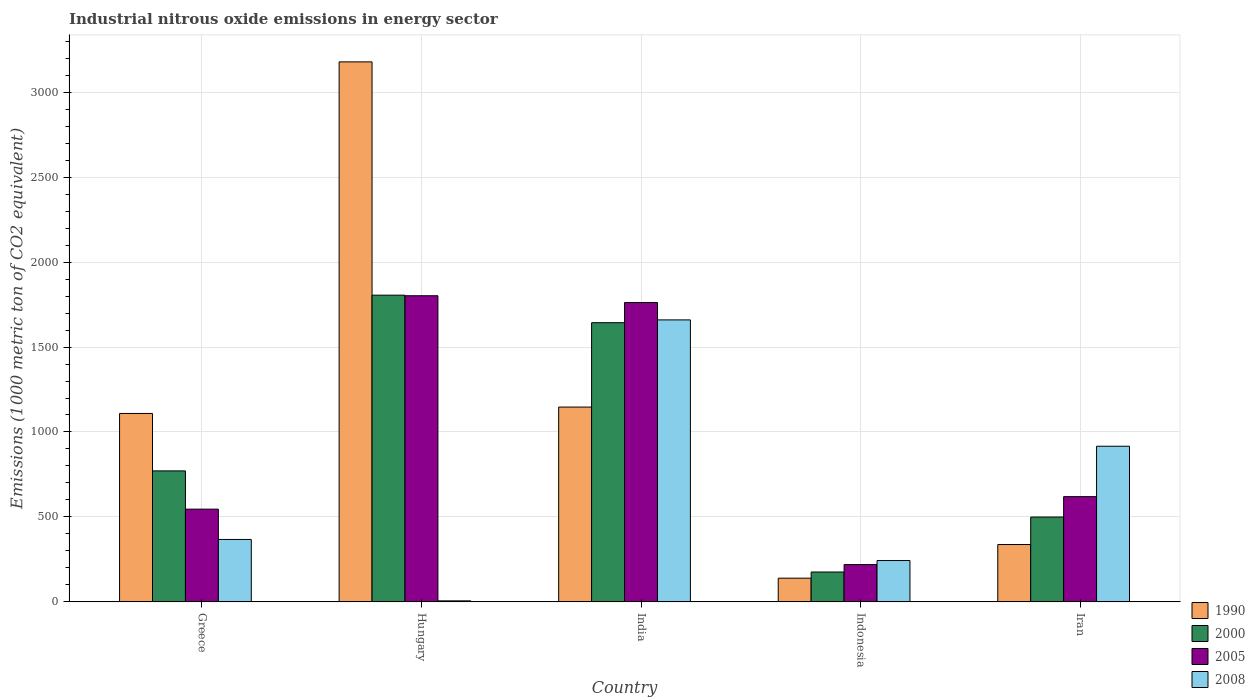Are the number of bars per tick equal to the number of legend labels?
Offer a terse response. Yes. How many bars are there on the 2nd tick from the left?
Provide a succinct answer. 4. In how many cases, is the number of bars for a given country not equal to the number of legend labels?
Offer a very short reply. 0. What is the amount of industrial nitrous oxide emitted in 2005 in Greece?
Ensure brevity in your answer.  545.8. Across all countries, what is the maximum amount of industrial nitrous oxide emitted in 1990?
Your response must be concise. 3178.6. Across all countries, what is the minimum amount of industrial nitrous oxide emitted in 2008?
Offer a terse response. 6. In which country was the amount of industrial nitrous oxide emitted in 2008 maximum?
Provide a succinct answer. India. In which country was the amount of industrial nitrous oxide emitted in 1990 minimum?
Offer a very short reply. Indonesia. What is the total amount of industrial nitrous oxide emitted in 2000 in the graph?
Provide a succinct answer. 4894.9. What is the difference between the amount of industrial nitrous oxide emitted in 2000 in Hungary and that in India?
Provide a short and direct response. 162.1. What is the difference between the amount of industrial nitrous oxide emitted in 1990 in Indonesia and the amount of industrial nitrous oxide emitted in 2008 in India?
Provide a succinct answer. -1520.3. What is the average amount of industrial nitrous oxide emitted in 2008 per country?
Offer a very short reply. 638.54. What is the difference between the amount of industrial nitrous oxide emitted of/in 2008 and amount of industrial nitrous oxide emitted of/in 1990 in Indonesia?
Offer a terse response. 103.8. In how many countries, is the amount of industrial nitrous oxide emitted in 2000 greater than 600 1000 metric ton?
Provide a succinct answer. 3. What is the ratio of the amount of industrial nitrous oxide emitted in 2008 in Greece to that in India?
Give a very brief answer. 0.22. Is the amount of industrial nitrous oxide emitted in 2005 in Hungary less than that in Indonesia?
Offer a very short reply. No. Is the difference between the amount of industrial nitrous oxide emitted in 2008 in India and Iran greater than the difference between the amount of industrial nitrous oxide emitted in 1990 in India and Iran?
Provide a short and direct response. No. What is the difference between the highest and the second highest amount of industrial nitrous oxide emitted in 2000?
Ensure brevity in your answer.  -872.3. What is the difference between the highest and the lowest amount of industrial nitrous oxide emitted in 2000?
Offer a terse response. 1629.6. Is it the case that in every country, the sum of the amount of industrial nitrous oxide emitted in 2000 and amount of industrial nitrous oxide emitted in 2008 is greater than the sum of amount of industrial nitrous oxide emitted in 2005 and amount of industrial nitrous oxide emitted in 1990?
Your response must be concise. No. What does the 3rd bar from the left in Hungary represents?
Ensure brevity in your answer.  2005. What does the 3rd bar from the right in Indonesia represents?
Offer a very short reply. 2000. Is it the case that in every country, the sum of the amount of industrial nitrous oxide emitted in 2008 and amount of industrial nitrous oxide emitted in 2000 is greater than the amount of industrial nitrous oxide emitted in 2005?
Offer a very short reply. Yes. How many bars are there?
Keep it short and to the point. 20. How many countries are there in the graph?
Your answer should be very brief. 5. What is the difference between two consecutive major ticks on the Y-axis?
Ensure brevity in your answer.  500. Where does the legend appear in the graph?
Offer a very short reply. Bottom right. How many legend labels are there?
Keep it short and to the point. 4. What is the title of the graph?
Your answer should be compact. Industrial nitrous oxide emissions in energy sector. Does "1995" appear as one of the legend labels in the graph?
Ensure brevity in your answer.  No. What is the label or title of the Y-axis?
Your answer should be very brief. Emissions (1000 metric ton of CO2 equivalent). What is the Emissions (1000 metric ton of CO2 equivalent) in 1990 in Greece?
Your response must be concise. 1109.1. What is the Emissions (1000 metric ton of CO2 equivalent) of 2000 in Greece?
Your response must be concise. 771. What is the Emissions (1000 metric ton of CO2 equivalent) of 2005 in Greece?
Give a very brief answer. 545.8. What is the Emissions (1000 metric ton of CO2 equivalent) in 2008 in Greece?
Your answer should be very brief. 367.4. What is the Emissions (1000 metric ton of CO2 equivalent) in 1990 in Hungary?
Keep it short and to the point. 3178.6. What is the Emissions (1000 metric ton of CO2 equivalent) in 2000 in Hungary?
Your answer should be compact. 1805.4. What is the Emissions (1000 metric ton of CO2 equivalent) in 2005 in Hungary?
Provide a succinct answer. 1802. What is the Emissions (1000 metric ton of CO2 equivalent) of 1990 in India?
Your response must be concise. 1146.7. What is the Emissions (1000 metric ton of CO2 equivalent) of 2000 in India?
Your response must be concise. 1643.3. What is the Emissions (1000 metric ton of CO2 equivalent) of 2005 in India?
Your response must be concise. 1761.9. What is the Emissions (1000 metric ton of CO2 equivalent) of 2008 in India?
Provide a short and direct response. 1659.8. What is the Emissions (1000 metric ton of CO2 equivalent) of 1990 in Indonesia?
Offer a terse response. 139.5. What is the Emissions (1000 metric ton of CO2 equivalent) in 2000 in Indonesia?
Your answer should be compact. 175.8. What is the Emissions (1000 metric ton of CO2 equivalent) of 2005 in Indonesia?
Offer a very short reply. 219.6. What is the Emissions (1000 metric ton of CO2 equivalent) in 2008 in Indonesia?
Your answer should be compact. 243.3. What is the Emissions (1000 metric ton of CO2 equivalent) of 1990 in Iran?
Offer a terse response. 337.6. What is the Emissions (1000 metric ton of CO2 equivalent) of 2000 in Iran?
Make the answer very short. 499.4. What is the Emissions (1000 metric ton of CO2 equivalent) of 2005 in Iran?
Offer a very short reply. 619.4. What is the Emissions (1000 metric ton of CO2 equivalent) in 2008 in Iran?
Provide a succinct answer. 916.2. Across all countries, what is the maximum Emissions (1000 metric ton of CO2 equivalent) of 1990?
Provide a short and direct response. 3178.6. Across all countries, what is the maximum Emissions (1000 metric ton of CO2 equivalent) of 2000?
Provide a short and direct response. 1805.4. Across all countries, what is the maximum Emissions (1000 metric ton of CO2 equivalent) of 2005?
Ensure brevity in your answer.  1802. Across all countries, what is the maximum Emissions (1000 metric ton of CO2 equivalent) in 2008?
Provide a short and direct response. 1659.8. Across all countries, what is the minimum Emissions (1000 metric ton of CO2 equivalent) in 1990?
Your answer should be compact. 139.5. Across all countries, what is the minimum Emissions (1000 metric ton of CO2 equivalent) of 2000?
Your response must be concise. 175.8. Across all countries, what is the minimum Emissions (1000 metric ton of CO2 equivalent) in 2005?
Your answer should be compact. 219.6. What is the total Emissions (1000 metric ton of CO2 equivalent) in 1990 in the graph?
Keep it short and to the point. 5911.5. What is the total Emissions (1000 metric ton of CO2 equivalent) of 2000 in the graph?
Provide a short and direct response. 4894.9. What is the total Emissions (1000 metric ton of CO2 equivalent) of 2005 in the graph?
Offer a very short reply. 4948.7. What is the total Emissions (1000 metric ton of CO2 equivalent) of 2008 in the graph?
Provide a succinct answer. 3192.7. What is the difference between the Emissions (1000 metric ton of CO2 equivalent) in 1990 in Greece and that in Hungary?
Keep it short and to the point. -2069.5. What is the difference between the Emissions (1000 metric ton of CO2 equivalent) of 2000 in Greece and that in Hungary?
Ensure brevity in your answer.  -1034.4. What is the difference between the Emissions (1000 metric ton of CO2 equivalent) in 2005 in Greece and that in Hungary?
Offer a terse response. -1256.2. What is the difference between the Emissions (1000 metric ton of CO2 equivalent) in 2008 in Greece and that in Hungary?
Offer a very short reply. 361.4. What is the difference between the Emissions (1000 metric ton of CO2 equivalent) of 1990 in Greece and that in India?
Offer a very short reply. -37.6. What is the difference between the Emissions (1000 metric ton of CO2 equivalent) of 2000 in Greece and that in India?
Your response must be concise. -872.3. What is the difference between the Emissions (1000 metric ton of CO2 equivalent) of 2005 in Greece and that in India?
Your response must be concise. -1216.1. What is the difference between the Emissions (1000 metric ton of CO2 equivalent) of 2008 in Greece and that in India?
Ensure brevity in your answer.  -1292.4. What is the difference between the Emissions (1000 metric ton of CO2 equivalent) of 1990 in Greece and that in Indonesia?
Keep it short and to the point. 969.6. What is the difference between the Emissions (1000 metric ton of CO2 equivalent) of 2000 in Greece and that in Indonesia?
Provide a succinct answer. 595.2. What is the difference between the Emissions (1000 metric ton of CO2 equivalent) in 2005 in Greece and that in Indonesia?
Offer a terse response. 326.2. What is the difference between the Emissions (1000 metric ton of CO2 equivalent) of 2008 in Greece and that in Indonesia?
Make the answer very short. 124.1. What is the difference between the Emissions (1000 metric ton of CO2 equivalent) in 1990 in Greece and that in Iran?
Your answer should be very brief. 771.5. What is the difference between the Emissions (1000 metric ton of CO2 equivalent) of 2000 in Greece and that in Iran?
Give a very brief answer. 271.6. What is the difference between the Emissions (1000 metric ton of CO2 equivalent) of 2005 in Greece and that in Iran?
Provide a short and direct response. -73.6. What is the difference between the Emissions (1000 metric ton of CO2 equivalent) in 2008 in Greece and that in Iran?
Provide a short and direct response. -548.8. What is the difference between the Emissions (1000 metric ton of CO2 equivalent) of 1990 in Hungary and that in India?
Keep it short and to the point. 2031.9. What is the difference between the Emissions (1000 metric ton of CO2 equivalent) of 2000 in Hungary and that in India?
Provide a short and direct response. 162.1. What is the difference between the Emissions (1000 metric ton of CO2 equivalent) of 2005 in Hungary and that in India?
Offer a terse response. 40.1. What is the difference between the Emissions (1000 metric ton of CO2 equivalent) in 2008 in Hungary and that in India?
Your answer should be very brief. -1653.8. What is the difference between the Emissions (1000 metric ton of CO2 equivalent) of 1990 in Hungary and that in Indonesia?
Provide a short and direct response. 3039.1. What is the difference between the Emissions (1000 metric ton of CO2 equivalent) in 2000 in Hungary and that in Indonesia?
Offer a terse response. 1629.6. What is the difference between the Emissions (1000 metric ton of CO2 equivalent) of 2005 in Hungary and that in Indonesia?
Your answer should be very brief. 1582.4. What is the difference between the Emissions (1000 metric ton of CO2 equivalent) of 2008 in Hungary and that in Indonesia?
Keep it short and to the point. -237.3. What is the difference between the Emissions (1000 metric ton of CO2 equivalent) in 1990 in Hungary and that in Iran?
Give a very brief answer. 2841. What is the difference between the Emissions (1000 metric ton of CO2 equivalent) in 2000 in Hungary and that in Iran?
Provide a short and direct response. 1306. What is the difference between the Emissions (1000 metric ton of CO2 equivalent) in 2005 in Hungary and that in Iran?
Ensure brevity in your answer.  1182.6. What is the difference between the Emissions (1000 metric ton of CO2 equivalent) of 2008 in Hungary and that in Iran?
Offer a very short reply. -910.2. What is the difference between the Emissions (1000 metric ton of CO2 equivalent) of 1990 in India and that in Indonesia?
Your answer should be compact. 1007.2. What is the difference between the Emissions (1000 metric ton of CO2 equivalent) in 2000 in India and that in Indonesia?
Make the answer very short. 1467.5. What is the difference between the Emissions (1000 metric ton of CO2 equivalent) of 2005 in India and that in Indonesia?
Make the answer very short. 1542.3. What is the difference between the Emissions (1000 metric ton of CO2 equivalent) of 2008 in India and that in Indonesia?
Keep it short and to the point. 1416.5. What is the difference between the Emissions (1000 metric ton of CO2 equivalent) of 1990 in India and that in Iran?
Keep it short and to the point. 809.1. What is the difference between the Emissions (1000 metric ton of CO2 equivalent) of 2000 in India and that in Iran?
Make the answer very short. 1143.9. What is the difference between the Emissions (1000 metric ton of CO2 equivalent) of 2005 in India and that in Iran?
Keep it short and to the point. 1142.5. What is the difference between the Emissions (1000 metric ton of CO2 equivalent) in 2008 in India and that in Iran?
Your answer should be compact. 743.6. What is the difference between the Emissions (1000 metric ton of CO2 equivalent) in 1990 in Indonesia and that in Iran?
Provide a short and direct response. -198.1. What is the difference between the Emissions (1000 metric ton of CO2 equivalent) of 2000 in Indonesia and that in Iran?
Provide a succinct answer. -323.6. What is the difference between the Emissions (1000 metric ton of CO2 equivalent) in 2005 in Indonesia and that in Iran?
Make the answer very short. -399.8. What is the difference between the Emissions (1000 metric ton of CO2 equivalent) of 2008 in Indonesia and that in Iran?
Keep it short and to the point. -672.9. What is the difference between the Emissions (1000 metric ton of CO2 equivalent) of 1990 in Greece and the Emissions (1000 metric ton of CO2 equivalent) of 2000 in Hungary?
Make the answer very short. -696.3. What is the difference between the Emissions (1000 metric ton of CO2 equivalent) in 1990 in Greece and the Emissions (1000 metric ton of CO2 equivalent) in 2005 in Hungary?
Give a very brief answer. -692.9. What is the difference between the Emissions (1000 metric ton of CO2 equivalent) in 1990 in Greece and the Emissions (1000 metric ton of CO2 equivalent) in 2008 in Hungary?
Keep it short and to the point. 1103.1. What is the difference between the Emissions (1000 metric ton of CO2 equivalent) in 2000 in Greece and the Emissions (1000 metric ton of CO2 equivalent) in 2005 in Hungary?
Offer a very short reply. -1031. What is the difference between the Emissions (1000 metric ton of CO2 equivalent) in 2000 in Greece and the Emissions (1000 metric ton of CO2 equivalent) in 2008 in Hungary?
Give a very brief answer. 765. What is the difference between the Emissions (1000 metric ton of CO2 equivalent) of 2005 in Greece and the Emissions (1000 metric ton of CO2 equivalent) of 2008 in Hungary?
Keep it short and to the point. 539.8. What is the difference between the Emissions (1000 metric ton of CO2 equivalent) of 1990 in Greece and the Emissions (1000 metric ton of CO2 equivalent) of 2000 in India?
Ensure brevity in your answer.  -534.2. What is the difference between the Emissions (1000 metric ton of CO2 equivalent) of 1990 in Greece and the Emissions (1000 metric ton of CO2 equivalent) of 2005 in India?
Your answer should be compact. -652.8. What is the difference between the Emissions (1000 metric ton of CO2 equivalent) in 1990 in Greece and the Emissions (1000 metric ton of CO2 equivalent) in 2008 in India?
Give a very brief answer. -550.7. What is the difference between the Emissions (1000 metric ton of CO2 equivalent) of 2000 in Greece and the Emissions (1000 metric ton of CO2 equivalent) of 2005 in India?
Your answer should be very brief. -990.9. What is the difference between the Emissions (1000 metric ton of CO2 equivalent) in 2000 in Greece and the Emissions (1000 metric ton of CO2 equivalent) in 2008 in India?
Offer a terse response. -888.8. What is the difference between the Emissions (1000 metric ton of CO2 equivalent) in 2005 in Greece and the Emissions (1000 metric ton of CO2 equivalent) in 2008 in India?
Offer a terse response. -1114. What is the difference between the Emissions (1000 metric ton of CO2 equivalent) in 1990 in Greece and the Emissions (1000 metric ton of CO2 equivalent) in 2000 in Indonesia?
Keep it short and to the point. 933.3. What is the difference between the Emissions (1000 metric ton of CO2 equivalent) in 1990 in Greece and the Emissions (1000 metric ton of CO2 equivalent) in 2005 in Indonesia?
Make the answer very short. 889.5. What is the difference between the Emissions (1000 metric ton of CO2 equivalent) in 1990 in Greece and the Emissions (1000 metric ton of CO2 equivalent) in 2008 in Indonesia?
Ensure brevity in your answer.  865.8. What is the difference between the Emissions (1000 metric ton of CO2 equivalent) of 2000 in Greece and the Emissions (1000 metric ton of CO2 equivalent) of 2005 in Indonesia?
Give a very brief answer. 551.4. What is the difference between the Emissions (1000 metric ton of CO2 equivalent) of 2000 in Greece and the Emissions (1000 metric ton of CO2 equivalent) of 2008 in Indonesia?
Provide a short and direct response. 527.7. What is the difference between the Emissions (1000 metric ton of CO2 equivalent) of 2005 in Greece and the Emissions (1000 metric ton of CO2 equivalent) of 2008 in Indonesia?
Provide a succinct answer. 302.5. What is the difference between the Emissions (1000 metric ton of CO2 equivalent) of 1990 in Greece and the Emissions (1000 metric ton of CO2 equivalent) of 2000 in Iran?
Ensure brevity in your answer.  609.7. What is the difference between the Emissions (1000 metric ton of CO2 equivalent) in 1990 in Greece and the Emissions (1000 metric ton of CO2 equivalent) in 2005 in Iran?
Provide a succinct answer. 489.7. What is the difference between the Emissions (1000 metric ton of CO2 equivalent) of 1990 in Greece and the Emissions (1000 metric ton of CO2 equivalent) of 2008 in Iran?
Offer a very short reply. 192.9. What is the difference between the Emissions (1000 metric ton of CO2 equivalent) in 2000 in Greece and the Emissions (1000 metric ton of CO2 equivalent) in 2005 in Iran?
Offer a very short reply. 151.6. What is the difference between the Emissions (1000 metric ton of CO2 equivalent) of 2000 in Greece and the Emissions (1000 metric ton of CO2 equivalent) of 2008 in Iran?
Make the answer very short. -145.2. What is the difference between the Emissions (1000 metric ton of CO2 equivalent) in 2005 in Greece and the Emissions (1000 metric ton of CO2 equivalent) in 2008 in Iran?
Your answer should be very brief. -370.4. What is the difference between the Emissions (1000 metric ton of CO2 equivalent) of 1990 in Hungary and the Emissions (1000 metric ton of CO2 equivalent) of 2000 in India?
Your answer should be compact. 1535.3. What is the difference between the Emissions (1000 metric ton of CO2 equivalent) in 1990 in Hungary and the Emissions (1000 metric ton of CO2 equivalent) in 2005 in India?
Keep it short and to the point. 1416.7. What is the difference between the Emissions (1000 metric ton of CO2 equivalent) in 1990 in Hungary and the Emissions (1000 metric ton of CO2 equivalent) in 2008 in India?
Provide a succinct answer. 1518.8. What is the difference between the Emissions (1000 metric ton of CO2 equivalent) in 2000 in Hungary and the Emissions (1000 metric ton of CO2 equivalent) in 2005 in India?
Give a very brief answer. 43.5. What is the difference between the Emissions (1000 metric ton of CO2 equivalent) of 2000 in Hungary and the Emissions (1000 metric ton of CO2 equivalent) of 2008 in India?
Your response must be concise. 145.6. What is the difference between the Emissions (1000 metric ton of CO2 equivalent) in 2005 in Hungary and the Emissions (1000 metric ton of CO2 equivalent) in 2008 in India?
Your answer should be compact. 142.2. What is the difference between the Emissions (1000 metric ton of CO2 equivalent) in 1990 in Hungary and the Emissions (1000 metric ton of CO2 equivalent) in 2000 in Indonesia?
Ensure brevity in your answer.  3002.8. What is the difference between the Emissions (1000 metric ton of CO2 equivalent) in 1990 in Hungary and the Emissions (1000 metric ton of CO2 equivalent) in 2005 in Indonesia?
Ensure brevity in your answer.  2959. What is the difference between the Emissions (1000 metric ton of CO2 equivalent) of 1990 in Hungary and the Emissions (1000 metric ton of CO2 equivalent) of 2008 in Indonesia?
Offer a terse response. 2935.3. What is the difference between the Emissions (1000 metric ton of CO2 equivalent) of 2000 in Hungary and the Emissions (1000 metric ton of CO2 equivalent) of 2005 in Indonesia?
Your answer should be compact. 1585.8. What is the difference between the Emissions (1000 metric ton of CO2 equivalent) in 2000 in Hungary and the Emissions (1000 metric ton of CO2 equivalent) in 2008 in Indonesia?
Offer a terse response. 1562.1. What is the difference between the Emissions (1000 metric ton of CO2 equivalent) in 2005 in Hungary and the Emissions (1000 metric ton of CO2 equivalent) in 2008 in Indonesia?
Make the answer very short. 1558.7. What is the difference between the Emissions (1000 metric ton of CO2 equivalent) of 1990 in Hungary and the Emissions (1000 metric ton of CO2 equivalent) of 2000 in Iran?
Keep it short and to the point. 2679.2. What is the difference between the Emissions (1000 metric ton of CO2 equivalent) in 1990 in Hungary and the Emissions (1000 metric ton of CO2 equivalent) in 2005 in Iran?
Your answer should be compact. 2559.2. What is the difference between the Emissions (1000 metric ton of CO2 equivalent) in 1990 in Hungary and the Emissions (1000 metric ton of CO2 equivalent) in 2008 in Iran?
Ensure brevity in your answer.  2262.4. What is the difference between the Emissions (1000 metric ton of CO2 equivalent) of 2000 in Hungary and the Emissions (1000 metric ton of CO2 equivalent) of 2005 in Iran?
Your answer should be compact. 1186. What is the difference between the Emissions (1000 metric ton of CO2 equivalent) in 2000 in Hungary and the Emissions (1000 metric ton of CO2 equivalent) in 2008 in Iran?
Offer a terse response. 889.2. What is the difference between the Emissions (1000 metric ton of CO2 equivalent) of 2005 in Hungary and the Emissions (1000 metric ton of CO2 equivalent) of 2008 in Iran?
Offer a very short reply. 885.8. What is the difference between the Emissions (1000 metric ton of CO2 equivalent) in 1990 in India and the Emissions (1000 metric ton of CO2 equivalent) in 2000 in Indonesia?
Provide a succinct answer. 970.9. What is the difference between the Emissions (1000 metric ton of CO2 equivalent) in 1990 in India and the Emissions (1000 metric ton of CO2 equivalent) in 2005 in Indonesia?
Make the answer very short. 927.1. What is the difference between the Emissions (1000 metric ton of CO2 equivalent) of 1990 in India and the Emissions (1000 metric ton of CO2 equivalent) of 2008 in Indonesia?
Ensure brevity in your answer.  903.4. What is the difference between the Emissions (1000 metric ton of CO2 equivalent) of 2000 in India and the Emissions (1000 metric ton of CO2 equivalent) of 2005 in Indonesia?
Offer a very short reply. 1423.7. What is the difference between the Emissions (1000 metric ton of CO2 equivalent) in 2000 in India and the Emissions (1000 metric ton of CO2 equivalent) in 2008 in Indonesia?
Provide a short and direct response. 1400. What is the difference between the Emissions (1000 metric ton of CO2 equivalent) of 2005 in India and the Emissions (1000 metric ton of CO2 equivalent) of 2008 in Indonesia?
Provide a short and direct response. 1518.6. What is the difference between the Emissions (1000 metric ton of CO2 equivalent) in 1990 in India and the Emissions (1000 metric ton of CO2 equivalent) in 2000 in Iran?
Provide a succinct answer. 647.3. What is the difference between the Emissions (1000 metric ton of CO2 equivalent) in 1990 in India and the Emissions (1000 metric ton of CO2 equivalent) in 2005 in Iran?
Give a very brief answer. 527.3. What is the difference between the Emissions (1000 metric ton of CO2 equivalent) of 1990 in India and the Emissions (1000 metric ton of CO2 equivalent) of 2008 in Iran?
Keep it short and to the point. 230.5. What is the difference between the Emissions (1000 metric ton of CO2 equivalent) of 2000 in India and the Emissions (1000 metric ton of CO2 equivalent) of 2005 in Iran?
Make the answer very short. 1023.9. What is the difference between the Emissions (1000 metric ton of CO2 equivalent) of 2000 in India and the Emissions (1000 metric ton of CO2 equivalent) of 2008 in Iran?
Your answer should be compact. 727.1. What is the difference between the Emissions (1000 metric ton of CO2 equivalent) in 2005 in India and the Emissions (1000 metric ton of CO2 equivalent) in 2008 in Iran?
Your answer should be compact. 845.7. What is the difference between the Emissions (1000 metric ton of CO2 equivalent) of 1990 in Indonesia and the Emissions (1000 metric ton of CO2 equivalent) of 2000 in Iran?
Give a very brief answer. -359.9. What is the difference between the Emissions (1000 metric ton of CO2 equivalent) of 1990 in Indonesia and the Emissions (1000 metric ton of CO2 equivalent) of 2005 in Iran?
Make the answer very short. -479.9. What is the difference between the Emissions (1000 metric ton of CO2 equivalent) of 1990 in Indonesia and the Emissions (1000 metric ton of CO2 equivalent) of 2008 in Iran?
Provide a succinct answer. -776.7. What is the difference between the Emissions (1000 metric ton of CO2 equivalent) of 2000 in Indonesia and the Emissions (1000 metric ton of CO2 equivalent) of 2005 in Iran?
Your answer should be very brief. -443.6. What is the difference between the Emissions (1000 metric ton of CO2 equivalent) in 2000 in Indonesia and the Emissions (1000 metric ton of CO2 equivalent) in 2008 in Iran?
Keep it short and to the point. -740.4. What is the difference between the Emissions (1000 metric ton of CO2 equivalent) in 2005 in Indonesia and the Emissions (1000 metric ton of CO2 equivalent) in 2008 in Iran?
Keep it short and to the point. -696.6. What is the average Emissions (1000 metric ton of CO2 equivalent) of 1990 per country?
Offer a terse response. 1182.3. What is the average Emissions (1000 metric ton of CO2 equivalent) of 2000 per country?
Offer a very short reply. 978.98. What is the average Emissions (1000 metric ton of CO2 equivalent) of 2005 per country?
Offer a terse response. 989.74. What is the average Emissions (1000 metric ton of CO2 equivalent) in 2008 per country?
Keep it short and to the point. 638.54. What is the difference between the Emissions (1000 metric ton of CO2 equivalent) of 1990 and Emissions (1000 metric ton of CO2 equivalent) of 2000 in Greece?
Offer a very short reply. 338.1. What is the difference between the Emissions (1000 metric ton of CO2 equivalent) in 1990 and Emissions (1000 metric ton of CO2 equivalent) in 2005 in Greece?
Keep it short and to the point. 563.3. What is the difference between the Emissions (1000 metric ton of CO2 equivalent) of 1990 and Emissions (1000 metric ton of CO2 equivalent) of 2008 in Greece?
Offer a terse response. 741.7. What is the difference between the Emissions (1000 metric ton of CO2 equivalent) in 2000 and Emissions (1000 metric ton of CO2 equivalent) in 2005 in Greece?
Provide a succinct answer. 225.2. What is the difference between the Emissions (1000 metric ton of CO2 equivalent) in 2000 and Emissions (1000 metric ton of CO2 equivalent) in 2008 in Greece?
Make the answer very short. 403.6. What is the difference between the Emissions (1000 metric ton of CO2 equivalent) in 2005 and Emissions (1000 metric ton of CO2 equivalent) in 2008 in Greece?
Your answer should be very brief. 178.4. What is the difference between the Emissions (1000 metric ton of CO2 equivalent) in 1990 and Emissions (1000 metric ton of CO2 equivalent) in 2000 in Hungary?
Offer a very short reply. 1373.2. What is the difference between the Emissions (1000 metric ton of CO2 equivalent) of 1990 and Emissions (1000 metric ton of CO2 equivalent) of 2005 in Hungary?
Your answer should be compact. 1376.6. What is the difference between the Emissions (1000 metric ton of CO2 equivalent) in 1990 and Emissions (1000 metric ton of CO2 equivalent) in 2008 in Hungary?
Offer a very short reply. 3172.6. What is the difference between the Emissions (1000 metric ton of CO2 equivalent) in 2000 and Emissions (1000 metric ton of CO2 equivalent) in 2008 in Hungary?
Your answer should be very brief. 1799.4. What is the difference between the Emissions (1000 metric ton of CO2 equivalent) of 2005 and Emissions (1000 metric ton of CO2 equivalent) of 2008 in Hungary?
Offer a terse response. 1796. What is the difference between the Emissions (1000 metric ton of CO2 equivalent) in 1990 and Emissions (1000 metric ton of CO2 equivalent) in 2000 in India?
Make the answer very short. -496.6. What is the difference between the Emissions (1000 metric ton of CO2 equivalent) of 1990 and Emissions (1000 metric ton of CO2 equivalent) of 2005 in India?
Offer a very short reply. -615.2. What is the difference between the Emissions (1000 metric ton of CO2 equivalent) in 1990 and Emissions (1000 metric ton of CO2 equivalent) in 2008 in India?
Make the answer very short. -513.1. What is the difference between the Emissions (1000 metric ton of CO2 equivalent) of 2000 and Emissions (1000 metric ton of CO2 equivalent) of 2005 in India?
Offer a very short reply. -118.6. What is the difference between the Emissions (1000 metric ton of CO2 equivalent) of 2000 and Emissions (1000 metric ton of CO2 equivalent) of 2008 in India?
Make the answer very short. -16.5. What is the difference between the Emissions (1000 metric ton of CO2 equivalent) of 2005 and Emissions (1000 metric ton of CO2 equivalent) of 2008 in India?
Ensure brevity in your answer.  102.1. What is the difference between the Emissions (1000 metric ton of CO2 equivalent) in 1990 and Emissions (1000 metric ton of CO2 equivalent) in 2000 in Indonesia?
Your answer should be compact. -36.3. What is the difference between the Emissions (1000 metric ton of CO2 equivalent) of 1990 and Emissions (1000 metric ton of CO2 equivalent) of 2005 in Indonesia?
Give a very brief answer. -80.1. What is the difference between the Emissions (1000 metric ton of CO2 equivalent) of 1990 and Emissions (1000 metric ton of CO2 equivalent) of 2008 in Indonesia?
Keep it short and to the point. -103.8. What is the difference between the Emissions (1000 metric ton of CO2 equivalent) of 2000 and Emissions (1000 metric ton of CO2 equivalent) of 2005 in Indonesia?
Make the answer very short. -43.8. What is the difference between the Emissions (1000 metric ton of CO2 equivalent) of 2000 and Emissions (1000 metric ton of CO2 equivalent) of 2008 in Indonesia?
Keep it short and to the point. -67.5. What is the difference between the Emissions (1000 metric ton of CO2 equivalent) of 2005 and Emissions (1000 metric ton of CO2 equivalent) of 2008 in Indonesia?
Provide a short and direct response. -23.7. What is the difference between the Emissions (1000 metric ton of CO2 equivalent) in 1990 and Emissions (1000 metric ton of CO2 equivalent) in 2000 in Iran?
Keep it short and to the point. -161.8. What is the difference between the Emissions (1000 metric ton of CO2 equivalent) in 1990 and Emissions (1000 metric ton of CO2 equivalent) in 2005 in Iran?
Keep it short and to the point. -281.8. What is the difference between the Emissions (1000 metric ton of CO2 equivalent) in 1990 and Emissions (1000 metric ton of CO2 equivalent) in 2008 in Iran?
Offer a very short reply. -578.6. What is the difference between the Emissions (1000 metric ton of CO2 equivalent) in 2000 and Emissions (1000 metric ton of CO2 equivalent) in 2005 in Iran?
Your answer should be compact. -120. What is the difference between the Emissions (1000 metric ton of CO2 equivalent) of 2000 and Emissions (1000 metric ton of CO2 equivalent) of 2008 in Iran?
Keep it short and to the point. -416.8. What is the difference between the Emissions (1000 metric ton of CO2 equivalent) in 2005 and Emissions (1000 metric ton of CO2 equivalent) in 2008 in Iran?
Offer a very short reply. -296.8. What is the ratio of the Emissions (1000 metric ton of CO2 equivalent) in 1990 in Greece to that in Hungary?
Your answer should be very brief. 0.35. What is the ratio of the Emissions (1000 metric ton of CO2 equivalent) in 2000 in Greece to that in Hungary?
Give a very brief answer. 0.43. What is the ratio of the Emissions (1000 metric ton of CO2 equivalent) of 2005 in Greece to that in Hungary?
Give a very brief answer. 0.3. What is the ratio of the Emissions (1000 metric ton of CO2 equivalent) of 2008 in Greece to that in Hungary?
Offer a very short reply. 61.23. What is the ratio of the Emissions (1000 metric ton of CO2 equivalent) in 1990 in Greece to that in India?
Ensure brevity in your answer.  0.97. What is the ratio of the Emissions (1000 metric ton of CO2 equivalent) of 2000 in Greece to that in India?
Ensure brevity in your answer.  0.47. What is the ratio of the Emissions (1000 metric ton of CO2 equivalent) of 2005 in Greece to that in India?
Your answer should be very brief. 0.31. What is the ratio of the Emissions (1000 metric ton of CO2 equivalent) in 2008 in Greece to that in India?
Ensure brevity in your answer.  0.22. What is the ratio of the Emissions (1000 metric ton of CO2 equivalent) of 1990 in Greece to that in Indonesia?
Ensure brevity in your answer.  7.95. What is the ratio of the Emissions (1000 metric ton of CO2 equivalent) of 2000 in Greece to that in Indonesia?
Keep it short and to the point. 4.39. What is the ratio of the Emissions (1000 metric ton of CO2 equivalent) in 2005 in Greece to that in Indonesia?
Offer a very short reply. 2.49. What is the ratio of the Emissions (1000 metric ton of CO2 equivalent) of 2008 in Greece to that in Indonesia?
Make the answer very short. 1.51. What is the ratio of the Emissions (1000 metric ton of CO2 equivalent) of 1990 in Greece to that in Iran?
Ensure brevity in your answer.  3.29. What is the ratio of the Emissions (1000 metric ton of CO2 equivalent) of 2000 in Greece to that in Iran?
Offer a terse response. 1.54. What is the ratio of the Emissions (1000 metric ton of CO2 equivalent) in 2005 in Greece to that in Iran?
Your response must be concise. 0.88. What is the ratio of the Emissions (1000 metric ton of CO2 equivalent) in 2008 in Greece to that in Iran?
Ensure brevity in your answer.  0.4. What is the ratio of the Emissions (1000 metric ton of CO2 equivalent) of 1990 in Hungary to that in India?
Ensure brevity in your answer.  2.77. What is the ratio of the Emissions (1000 metric ton of CO2 equivalent) of 2000 in Hungary to that in India?
Provide a short and direct response. 1.1. What is the ratio of the Emissions (1000 metric ton of CO2 equivalent) in 2005 in Hungary to that in India?
Your response must be concise. 1.02. What is the ratio of the Emissions (1000 metric ton of CO2 equivalent) in 2008 in Hungary to that in India?
Offer a terse response. 0. What is the ratio of the Emissions (1000 metric ton of CO2 equivalent) in 1990 in Hungary to that in Indonesia?
Offer a terse response. 22.79. What is the ratio of the Emissions (1000 metric ton of CO2 equivalent) of 2000 in Hungary to that in Indonesia?
Provide a short and direct response. 10.27. What is the ratio of the Emissions (1000 metric ton of CO2 equivalent) in 2005 in Hungary to that in Indonesia?
Keep it short and to the point. 8.21. What is the ratio of the Emissions (1000 metric ton of CO2 equivalent) of 2008 in Hungary to that in Indonesia?
Give a very brief answer. 0.02. What is the ratio of the Emissions (1000 metric ton of CO2 equivalent) in 1990 in Hungary to that in Iran?
Make the answer very short. 9.42. What is the ratio of the Emissions (1000 metric ton of CO2 equivalent) of 2000 in Hungary to that in Iran?
Make the answer very short. 3.62. What is the ratio of the Emissions (1000 metric ton of CO2 equivalent) in 2005 in Hungary to that in Iran?
Your response must be concise. 2.91. What is the ratio of the Emissions (1000 metric ton of CO2 equivalent) in 2008 in Hungary to that in Iran?
Your answer should be compact. 0.01. What is the ratio of the Emissions (1000 metric ton of CO2 equivalent) in 1990 in India to that in Indonesia?
Offer a terse response. 8.22. What is the ratio of the Emissions (1000 metric ton of CO2 equivalent) in 2000 in India to that in Indonesia?
Provide a short and direct response. 9.35. What is the ratio of the Emissions (1000 metric ton of CO2 equivalent) in 2005 in India to that in Indonesia?
Keep it short and to the point. 8.02. What is the ratio of the Emissions (1000 metric ton of CO2 equivalent) of 2008 in India to that in Indonesia?
Make the answer very short. 6.82. What is the ratio of the Emissions (1000 metric ton of CO2 equivalent) of 1990 in India to that in Iran?
Provide a short and direct response. 3.4. What is the ratio of the Emissions (1000 metric ton of CO2 equivalent) of 2000 in India to that in Iran?
Offer a very short reply. 3.29. What is the ratio of the Emissions (1000 metric ton of CO2 equivalent) in 2005 in India to that in Iran?
Give a very brief answer. 2.84. What is the ratio of the Emissions (1000 metric ton of CO2 equivalent) of 2008 in India to that in Iran?
Your response must be concise. 1.81. What is the ratio of the Emissions (1000 metric ton of CO2 equivalent) in 1990 in Indonesia to that in Iran?
Offer a terse response. 0.41. What is the ratio of the Emissions (1000 metric ton of CO2 equivalent) in 2000 in Indonesia to that in Iran?
Provide a short and direct response. 0.35. What is the ratio of the Emissions (1000 metric ton of CO2 equivalent) of 2005 in Indonesia to that in Iran?
Your answer should be compact. 0.35. What is the ratio of the Emissions (1000 metric ton of CO2 equivalent) of 2008 in Indonesia to that in Iran?
Provide a short and direct response. 0.27. What is the difference between the highest and the second highest Emissions (1000 metric ton of CO2 equivalent) of 1990?
Ensure brevity in your answer.  2031.9. What is the difference between the highest and the second highest Emissions (1000 metric ton of CO2 equivalent) of 2000?
Your answer should be compact. 162.1. What is the difference between the highest and the second highest Emissions (1000 metric ton of CO2 equivalent) in 2005?
Offer a very short reply. 40.1. What is the difference between the highest and the second highest Emissions (1000 metric ton of CO2 equivalent) in 2008?
Your answer should be very brief. 743.6. What is the difference between the highest and the lowest Emissions (1000 metric ton of CO2 equivalent) of 1990?
Your answer should be very brief. 3039.1. What is the difference between the highest and the lowest Emissions (1000 metric ton of CO2 equivalent) in 2000?
Provide a succinct answer. 1629.6. What is the difference between the highest and the lowest Emissions (1000 metric ton of CO2 equivalent) of 2005?
Offer a very short reply. 1582.4. What is the difference between the highest and the lowest Emissions (1000 metric ton of CO2 equivalent) of 2008?
Provide a short and direct response. 1653.8. 